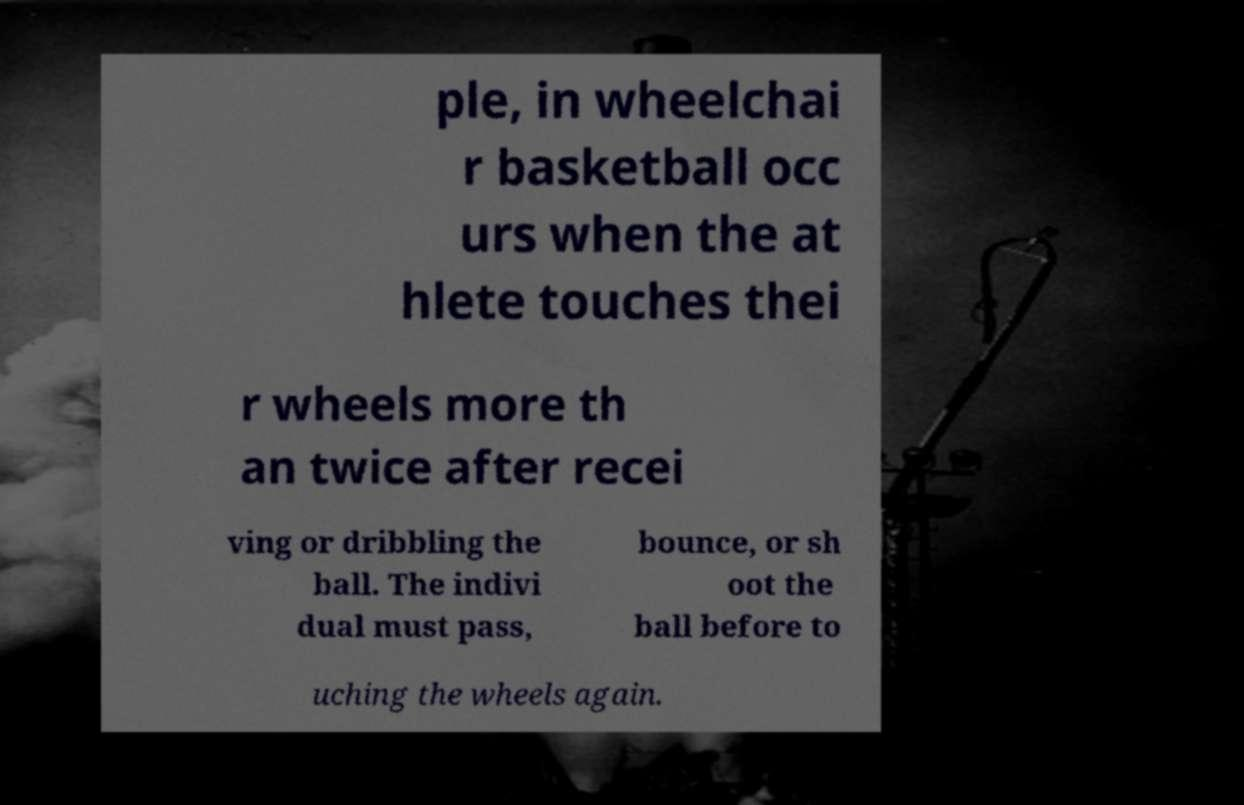Could you assist in decoding the text presented in this image and type it out clearly? ple, in wheelchai r basketball occ urs when the at hlete touches thei r wheels more th an twice after recei ving or dribbling the ball. The indivi dual must pass, bounce, or sh oot the ball before to uching the wheels again. 